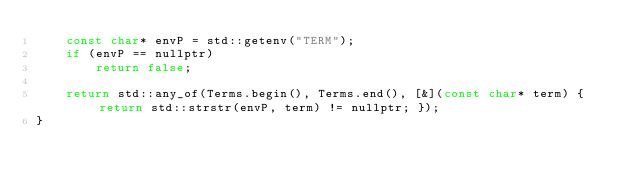Convert code to text. <code><loc_0><loc_0><loc_500><loc_500><_C++_>	const char* envP = std::getenv("TERM");
	if (envP == nullptr)
		return false;

	return std::any_of(Terms.begin(), Terms.end(), [&](const char* term) {return std::strstr(envP, term) != nullptr; });
}</code> 